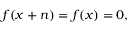Convert formula to latex. <formula><loc_0><loc_0><loc_500><loc_500>f ( x + n ) = f ( x ) = 0 ,</formula> 